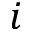Convert formula to latex. <formula><loc_0><loc_0><loc_500><loc_500>i</formula> 